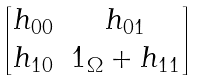Convert formula to latex. <formula><loc_0><loc_0><loc_500><loc_500>\begin{bmatrix} h _ { 0 0 } & h _ { 0 1 } \\ h _ { 1 0 } & 1 _ { \Omega } + h _ { 1 1 } \end{bmatrix}</formula> 